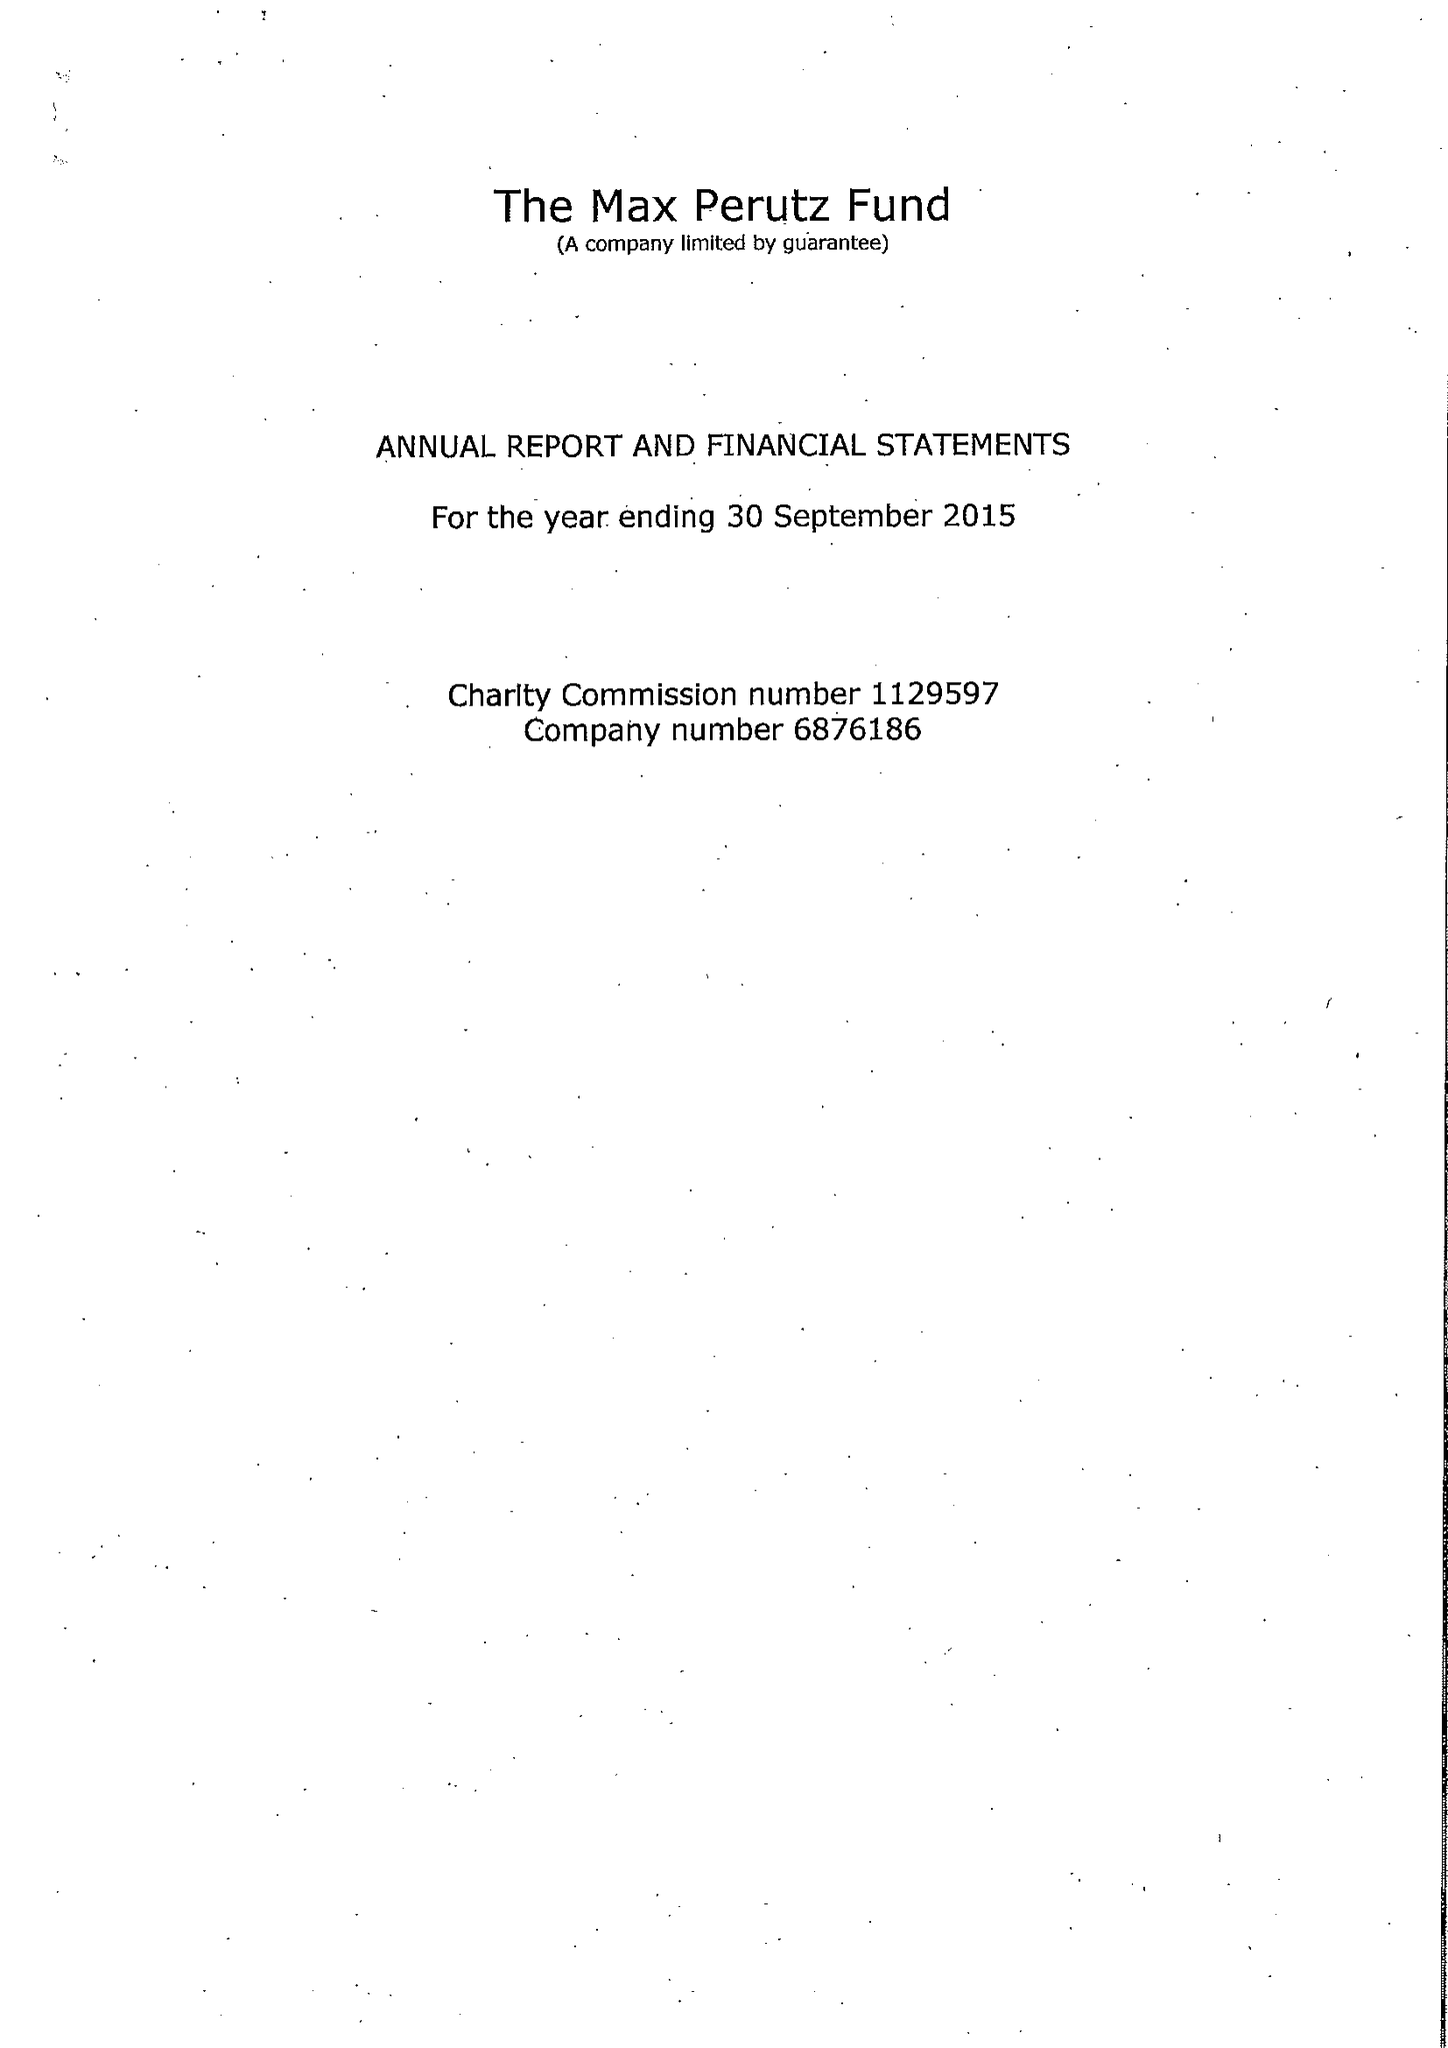What is the value for the address__street_line?
Answer the question using a single word or phrase. FRANCIS CRICK AVENUE 